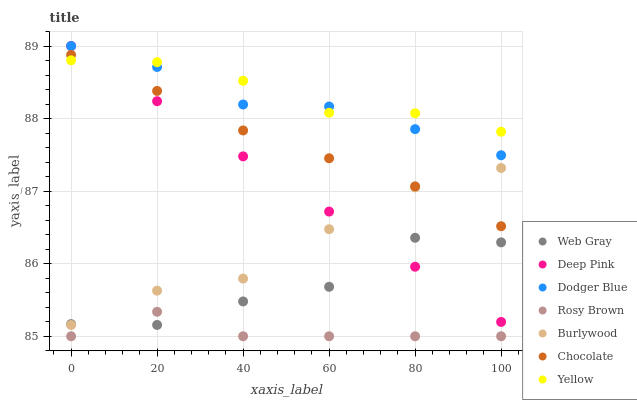Does Rosy Brown have the minimum area under the curve?
Answer yes or no. Yes. Does Yellow have the maximum area under the curve?
Answer yes or no. Yes. Does Burlywood have the minimum area under the curve?
Answer yes or no. No. Does Burlywood have the maximum area under the curve?
Answer yes or no. No. Is Deep Pink the smoothest?
Answer yes or no. Yes. Is Web Gray the roughest?
Answer yes or no. Yes. Is Burlywood the smoothest?
Answer yes or no. No. Is Burlywood the roughest?
Answer yes or no. No. Does Rosy Brown have the lowest value?
Answer yes or no. Yes. Does Burlywood have the lowest value?
Answer yes or no. No. Does Dodger Blue have the highest value?
Answer yes or no. Yes. Does Burlywood have the highest value?
Answer yes or no. No. Is Rosy Brown less than Burlywood?
Answer yes or no. Yes. Is Dodger Blue greater than Web Gray?
Answer yes or no. Yes. Does Rosy Brown intersect Web Gray?
Answer yes or no. Yes. Is Rosy Brown less than Web Gray?
Answer yes or no. No. Is Rosy Brown greater than Web Gray?
Answer yes or no. No. Does Rosy Brown intersect Burlywood?
Answer yes or no. No. 